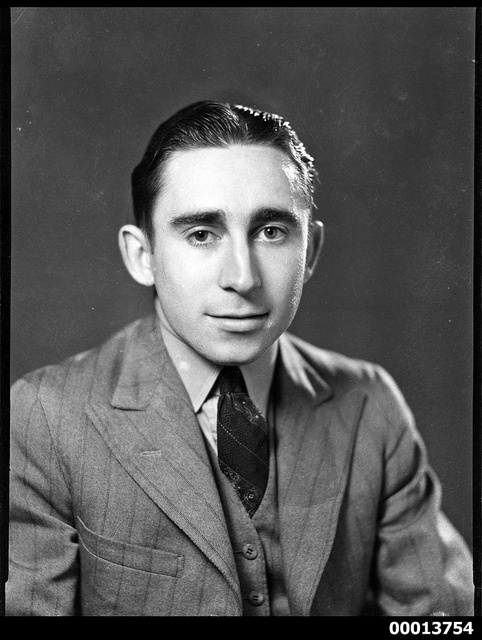Describe the objects in this image and their specific colors. I can see people in black, gray, darkgray, and lightgray tones and tie in black, gray, and lightgray tones in this image. 